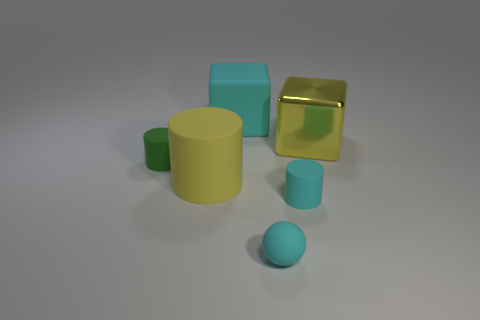How many things are both behind the big yellow cylinder and on the right side of the cyan sphere?
Provide a short and direct response. 1. Are there any big cyan rubber cubes on the left side of the tiny matte cylinder that is to the right of the sphere that is in front of the big yellow metallic object?
Your answer should be compact. Yes. There is a cyan object that is the same size as the yellow metal block; what is its shape?
Offer a very short reply. Cube. Is there a large block that has the same color as the rubber sphere?
Provide a short and direct response. Yes. Does the green object have the same shape as the yellow rubber object?
Your answer should be compact. Yes. What number of big things are either green rubber objects or yellow blocks?
Your response must be concise. 1. What color is the block that is made of the same material as the tiny green thing?
Your response must be concise. Cyan. How many tiny green cylinders are the same material as the cyan cube?
Give a very brief answer. 1. There is a cyan thing that is behind the yellow matte cylinder; is its size the same as the yellow thing in front of the yellow cube?
Make the answer very short. Yes. The big thing that is on the right side of the cylinder on the right side of the big cyan matte thing is made of what material?
Ensure brevity in your answer.  Metal. 